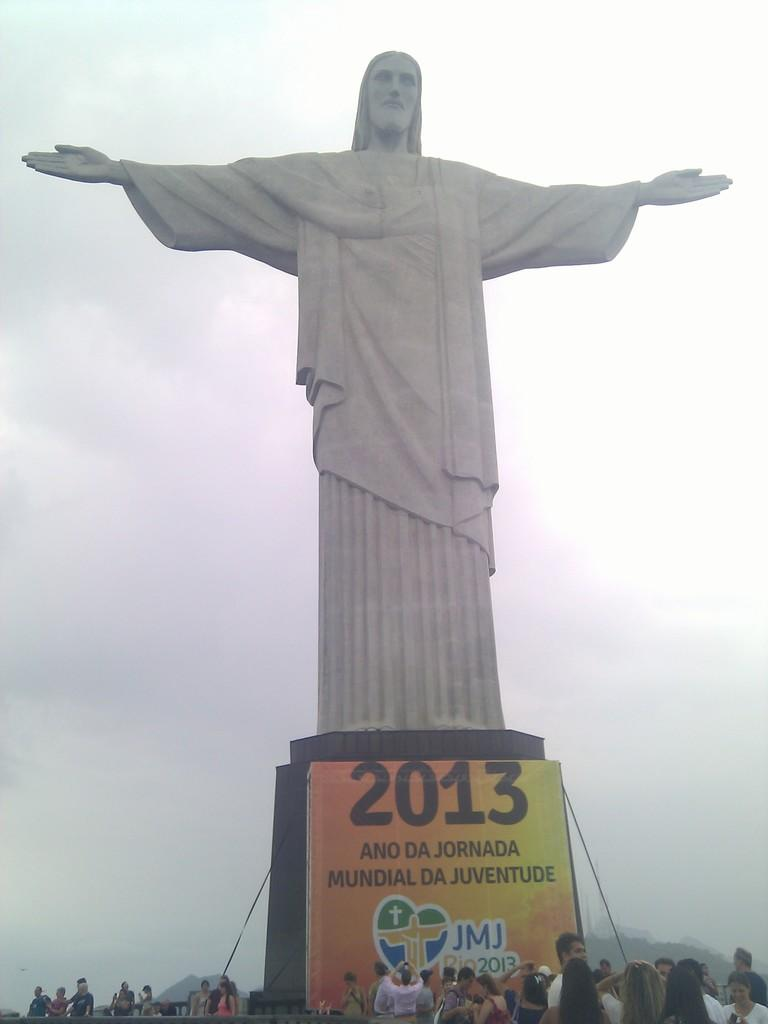What is the main subject in the image? There is an idol statue in the image. What else can be seen in the image besides the statue? There is a banner with text in the image, and the banner displays a year. Are there any people present in the image? Yes, there are people at the bottom of the image. What can be seen in the background of the image? The sky is visible in the background of the image, and it appears to be cloudy. What type of design can be seen on the shoes of the people in the image? There is no information about the people's shoes in the image, so we cannot determine the design. 